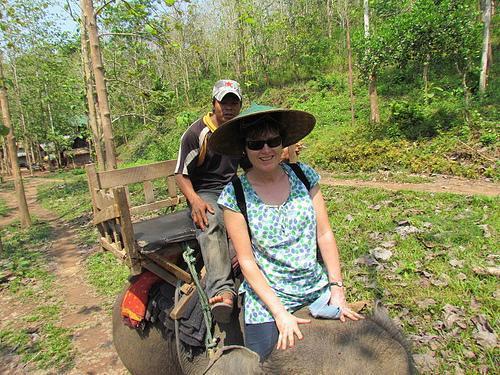How many people are in the picture?
Give a very brief answer. 2. 